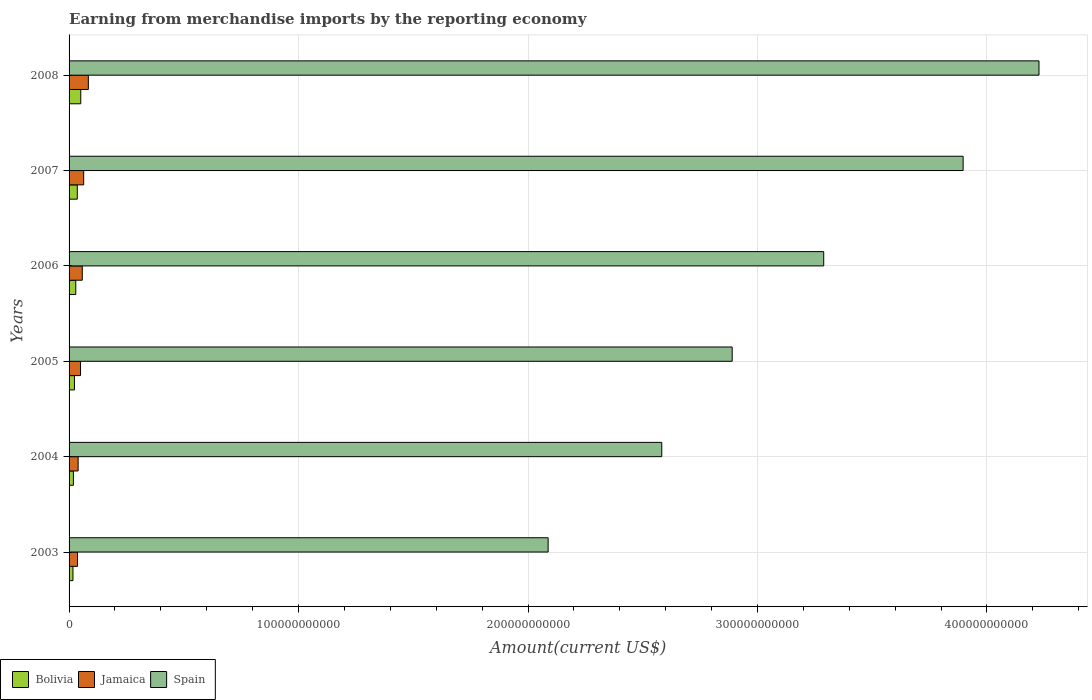Are the number of bars on each tick of the Y-axis equal?
Ensure brevity in your answer.  Yes. What is the amount earned from merchandise imports in Spain in 2007?
Offer a very short reply. 3.90e+11. Across all years, what is the maximum amount earned from merchandise imports in Jamaica?
Ensure brevity in your answer.  8.40e+09. Across all years, what is the minimum amount earned from merchandise imports in Spain?
Offer a very short reply. 2.09e+11. In which year was the amount earned from merchandise imports in Bolivia minimum?
Keep it short and to the point. 2003. What is the total amount earned from merchandise imports in Bolivia in the graph?
Keep it short and to the point. 1.75e+1. What is the difference between the amount earned from merchandise imports in Bolivia in 2003 and that in 2008?
Offer a very short reply. -3.41e+09. What is the difference between the amount earned from merchandise imports in Jamaica in 2008 and the amount earned from merchandise imports in Bolivia in 2007?
Make the answer very short. 4.81e+09. What is the average amount earned from merchandise imports in Jamaica per year?
Your answer should be compact. 5.52e+09. In the year 2008, what is the difference between the amount earned from merchandise imports in Spain and amount earned from merchandise imports in Jamaica?
Make the answer very short. 4.14e+11. What is the ratio of the amount earned from merchandise imports in Bolivia in 2003 to that in 2006?
Ensure brevity in your answer.  0.58. Is the amount earned from merchandise imports in Spain in 2003 less than that in 2006?
Make the answer very short. Yes. Is the difference between the amount earned from merchandise imports in Spain in 2006 and 2007 greater than the difference between the amount earned from merchandise imports in Jamaica in 2006 and 2007?
Ensure brevity in your answer.  No. What is the difference between the highest and the second highest amount earned from merchandise imports in Spain?
Your answer should be very brief. 3.31e+1. What is the difference between the highest and the lowest amount earned from merchandise imports in Bolivia?
Give a very brief answer. 3.41e+09. Is the sum of the amount earned from merchandise imports in Bolivia in 2005 and 2007 greater than the maximum amount earned from merchandise imports in Spain across all years?
Provide a succinct answer. No. What does the 2nd bar from the top in 2005 represents?
Give a very brief answer. Jamaica. What does the 1st bar from the bottom in 2007 represents?
Your answer should be very brief. Bolivia. How many years are there in the graph?
Ensure brevity in your answer.  6. What is the difference between two consecutive major ticks on the X-axis?
Make the answer very short. 1.00e+11. Are the values on the major ticks of X-axis written in scientific E-notation?
Your response must be concise. No. Does the graph contain any zero values?
Provide a succinct answer. No. Does the graph contain grids?
Ensure brevity in your answer.  Yes. Where does the legend appear in the graph?
Your answer should be very brief. Bottom left. How many legend labels are there?
Ensure brevity in your answer.  3. How are the legend labels stacked?
Your answer should be compact. Horizontal. What is the title of the graph?
Give a very brief answer. Earning from merchandise imports by the reporting economy. What is the label or title of the X-axis?
Offer a very short reply. Amount(current US$). What is the Amount(current US$) in Bolivia in 2003?
Offer a very short reply. 1.69e+09. What is the Amount(current US$) of Jamaica in 2003?
Provide a short and direct response. 3.67e+09. What is the Amount(current US$) in Spain in 2003?
Give a very brief answer. 2.09e+11. What is the Amount(current US$) in Bolivia in 2004?
Your answer should be compact. 1.89e+09. What is the Amount(current US$) of Jamaica in 2004?
Offer a very short reply. 3.95e+09. What is the Amount(current US$) of Spain in 2004?
Make the answer very short. 2.58e+11. What is the Amount(current US$) in Bolivia in 2005?
Provide a short and direct response. 2.34e+09. What is the Amount(current US$) in Jamaica in 2005?
Ensure brevity in your answer.  4.99e+09. What is the Amount(current US$) of Spain in 2005?
Your answer should be compact. 2.89e+11. What is the Amount(current US$) in Bolivia in 2006?
Give a very brief answer. 2.93e+09. What is the Amount(current US$) of Jamaica in 2006?
Offer a terse response. 5.75e+09. What is the Amount(current US$) in Spain in 2006?
Offer a very short reply. 3.29e+11. What is the Amount(current US$) of Bolivia in 2007?
Your answer should be compact. 3.59e+09. What is the Amount(current US$) in Jamaica in 2007?
Provide a short and direct response. 6.37e+09. What is the Amount(current US$) of Spain in 2007?
Your response must be concise. 3.90e+11. What is the Amount(current US$) in Bolivia in 2008?
Keep it short and to the point. 5.10e+09. What is the Amount(current US$) in Jamaica in 2008?
Provide a succinct answer. 8.40e+09. What is the Amount(current US$) in Spain in 2008?
Keep it short and to the point. 4.23e+11. Across all years, what is the maximum Amount(current US$) of Bolivia?
Provide a succinct answer. 5.10e+09. Across all years, what is the maximum Amount(current US$) in Jamaica?
Ensure brevity in your answer.  8.40e+09. Across all years, what is the maximum Amount(current US$) of Spain?
Offer a terse response. 4.23e+11. Across all years, what is the minimum Amount(current US$) of Bolivia?
Offer a very short reply. 1.69e+09. Across all years, what is the minimum Amount(current US$) in Jamaica?
Offer a very short reply. 3.67e+09. Across all years, what is the minimum Amount(current US$) of Spain?
Offer a terse response. 2.09e+11. What is the total Amount(current US$) in Bolivia in the graph?
Provide a succinct answer. 1.75e+1. What is the total Amount(current US$) in Jamaica in the graph?
Keep it short and to the point. 3.31e+1. What is the total Amount(current US$) in Spain in the graph?
Give a very brief answer. 1.90e+12. What is the difference between the Amount(current US$) in Bolivia in 2003 and that in 2004?
Ensure brevity in your answer.  -1.96e+08. What is the difference between the Amount(current US$) of Jamaica in 2003 and that in 2004?
Offer a very short reply. -2.81e+08. What is the difference between the Amount(current US$) of Spain in 2003 and that in 2004?
Ensure brevity in your answer.  -4.95e+1. What is the difference between the Amount(current US$) in Bolivia in 2003 and that in 2005?
Offer a very short reply. -6.51e+08. What is the difference between the Amount(current US$) in Jamaica in 2003 and that in 2005?
Provide a short and direct response. -1.32e+09. What is the difference between the Amount(current US$) of Spain in 2003 and that in 2005?
Make the answer very short. -8.02e+1. What is the difference between the Amount(current US$) of Bolivia in 2003 and that in 2006?
Give a very brief answer. -1.23e+09. What is the difference between the Amount(current US$) of Jamaica in 2003 and that in 2006?
Provide a succinct answer. -2.08e+09. What is the difference between the Amount(current US$) in Spain in 2003 and that in 2006?
Ensure brevity in your answer.  -1.20e+11. What is the difference between the Amount(current US$) of Bolivia in 2003 and that in 2007?
Your response must be concise. -1.90e+09. What is the difference between the Amount(current US$) of Jamaica in 2003 and that in 2007?
Offer a very short reply. -2.70e+09. What is the difference between the Amount(current US$) in Spain in 2003 and that in 2007?
Make the answer very short. -1.81e+11. What is the difference between the Amount(current US$) of Bolivia in 2003 and that in 2008?
Your response must be concise. -3.41e+09. What is the difference between the Amount(current US$) in Jamaica in 2003 and that in 2008?
Your answer should be very brief. -4.73e+09. What is the difference between the Amount(current US$) of Spain in 2003 and that in 2008?
Ensure brevity in your answer.  -2.14e+11. What is the difference between the Amount(current US$) in Bolivia in 2004 and that in 2005?
Your answer should be compact. -4.56e+08. What is the difference between the Amount(current US$) in Jamaica in 2004 and that in 2005?
Your response must be concise. -1.04e+09. What is the difference between the Amount(current US$) in Spain in 2004 and that in 2005?
Offer a very short reply. -3.07e+1. What is the difference between the Amount(current US$) of Bolivia in 2004 and that in 2006?
Make the answer very short. -1.04e+09. What is the difference between the Amount(current US$) of Jamaica in 2004 and that in 2006?
Give a very brief answer. -1.80e+09. What is the difference between the Amount(current US$) in Spain in 2004 and that in 2006?
Keep it short and to the point. -7.06e+1. What is the difference between the Amount(current US$) in Bolivia in 2004 and that in 2007?
Provide a succinct answer. -1.70e+09. What is the difference between the Amount(current US$) of Jamaica in 2004 and that in 2007?
Provide a succinct answer. -2.42e+09. What is the difference between the Amount(current US$) of Spain in 2004 and that in 2007?
Your answer should be compact. -1.31e+11. What is the difference between the Amount(current US$) in Bolivia in 2004 and that in 2008?
Provide a short and direct response. -3.21e+09. What is the difference between the Amount(current US$) of Jamaica in 2004 and that in 2008?
Give a very brief answer. -4.44e+09. What is the difference between the Amount(current US$) in Spain in 2004 and that in 2008?
Ensure brevity in your answer.  -1.64e+11. What is the difference between the Amount(current US$) in Bolivia in 2005 and that in 2006?
Your answer should be very brief. -5.82e+08. What is the difference between the Amount(current US$) in Jamaica in 2005 and that in 2006?
Provide a succinct answer. -7.57e+08. What is the difference between the Amount(current US$) of Spain in 2005 and that in 2006?
Keep it short and to the point. -3.99e+1. What is the difference between the Amount(current US$) in Bolivia in 2005 and that in 2007?
Make the answer very short. -1.24e+09. What is the difference between the Amount(current US$) of Jamaica in 2005 and that in 2007?
Make the answer very short. -1.38e+09. What is the difference between the Amount(current US$) in Spain in 2005 and that in 2007?
Provide a succinct answer. -1.01e+11. What is the difference between the Amount(current US$) of Bolivia in 2005 and that in 2008?
Make the answer very short. -2.76e+09. What is the difference between the Amount(current US$) in Jamaica in 2005 and that in 2008?
Ensure brevity in your answer.  -3.41e+09. What is the difference between the Amount(current US$) of Spain in 2005 and that in 2008?
Ensure brevity in your answer.  -1.34e+11. What is the difference between the Amount(current US$) of Bolivia in 2006 and that in 2007?
Make the answer very short. -6.62e+08. What is the difference between the Amount(current US$) in Jamaica in 2006 and that in 2007?
Provide a short and direct response. -6.19e+08. What is the difference between the Amount(current US$) of Spain in 2006 and that in 2007?
Your answer should be very brief. -6.07e+1. What is the difference between the Amount(current US$) in Bolivia in 2006 and that in 2008?
Provide a short and direct response. -2.17e+09. What is the difference between the Amount(current US$) of Jamaica in 2006 and that in 2008?
Provide a short and direct response. -2.65e+09. What is the difference between the Amount(current US$) of Spain in 2006 and that in 2008?
Provide a short and direct response. -9.38e+1. What is the difference between the Amount(current US$) of Bolivia in 2007 and that in 2008?
Give a very brief answer. -1.51e+09. What is the difference between the Amount(current US$) in Jamaica in 2007 and that in 2008?
Keep it short and to the point. -2.03e+09. What is the difference between the Amount(current US$) of Spain in 2007 and that in 2008?
Ensure brevity in your answer.  -3.31e+1. What is the difference between the Amount(current US$) in Bolivia in 2003 and the Amount(current US$) in Jamaica in 2004?
Your answer should be compact. -2.26e+09. What is the difference between the Amount(current US$) in Bolivia in 2003 and the Amount(current US$) in Spain in 2004?
Provide a short and direct response. -2.57e+11. What is the difference between the Amount(current US$) in Jamaica in 2003 and the Amount(current US$) in Spain in 2004?
Make the answer very short. -2.55e+11. What is the difference between the Amount(current US$) of Bolivia in 2003 and the Amount(current US$) of Jamaica in 2005?
Your answer should be compact. -3.30e+09. What is the difference between the Amount(current US$) in Bolivia in 2003 and the Amount(current US$) in Spain in 2005?
Keep it short and to the point. -2.87e+11. What is the difference between the Amount(current US$) in Jamaica in 2003 and the Amount(current US$) in Spain in 2005?
Your answer should be very brief. -2.85e+11. What is the difference between the Amount(current US$) in Bolivia in 2003 and the Amount(current US$) in Jamaica in 2006?
Your answer should be compact. -4.06e+09. What is the difference between the Amount(current US$) of Bolivia in 2003 and the Amount(current US$) of Spain in 2006?
Make the answer very short. -3.27e+11. What is the difference between the Amount(current US$) in Jamaica in 2003 and the Amount(current US$) in Spain in 2006?
Your answer should be very brief. -3.25e+11. What is the difference between the Amount(current US$) in Bolivia in 2003 and the Amount(current US$) in Jamaica in 2007?
Ensure brevity in your answer.  -4.68e+09. What is the difference between the Amount(current US$) in Bolivia in 2003 and the Amount(current US$) in Spain in 2007?
Your answer should be compact. -3.88e+11. What is the difference between the Amount(current US$) in Jamaica in 2003 and the Amount(current US$) in Spain in 2007?
Make the answer very short. -3.86e+11. What is the difference between the Amount(current US$) in Bolivia in 2003 and the Amount(current US$) in Jamaica in 2008?
Keep it short and to the point. -6.71e+09. What is the difference between the Amount(current US$) of Bolivia in 2003 and the Amount(current US$) of Spain in 2008?
Provide a succinct answer. -4.21e+11. What is the difference between the Amount(current US$) in Jamaica in 2003 and the Amount(current US$) in Spain in 2008?
Offer a very short reply. -4.19e+11. What is the difference between the Amount(current US$) of Bolivia in 2004 and the Amount(current US$) of Jamaica in 2005?
Give a very brief answer. -3.10e+09. What is the difference between the Amount(current US$) in Bolivia in 2004 and the Amount(current US$) in Spain in 2005?
Keep it short and to the point. -2.87e+11. What is the difference between the Amount(current US$) in Jamaica in 2004 and the Amount(current US$) in Spain in 2005?
Your answer should be compact. -2.85e+11. What is the difference between the Amount(current US$) of Bolivia in 2004 and the Amount(current US$) of Jamaica in 2006?
Provide a succinct answer. -3.86e+09. What is the difference between the Amount(current US$) in Bolivia in 2004 and the Amount(current US$) in Spain in 2006?
Provide a succinct answer. -3.27e+11. What is the difference between the Amount(current US$) of Jamaica in 2004 and the Amount(current US$) of Spain in 2006?
Offer a terse response. -3.25e+11. What is the difference between the Amount(current US$) of Bolivia in 2004 and the Amount(current US$) of Jamaica in 2007?
Provide a short and direct response. -4.48e+09. What is the difference between the Amount(current US$) of Bolivia in 2004 and the Amount(current US$) of Spain in 2007?
Provide a succinct answer. -3.88e+11. What is the difference between the Amount(current US$) of Jamaica in 2004 and the Amount(current US$) of Spain in 2007?
Make the answer very short. -3.86e+11. What is the difference between the Amount(current US$) of Bolivia in 2004 and the Amount(current US$) of Jamaica in 2008?
Keep it short and to the point. -6.51e+09. What is the difference between the Amount(current US$) in Bolivia in 2004 and the Amount(current US$) in Spain in 2008?
Your answer should be very brief. -4.21e+11. What is the difference between the Amount(current US$) of Jamaica in 2004 and the Amount(current US$) of Spain in 2008?
Your answer should be very brief. -4.19e+11. What is the difference between the Amount(current US$) in Bolivia in 2005 and the Amount(current US$) in Jamaica in 2006?
Give a very brief answer. -3.41e+09. What is the difference between the Amount(current US$) of Bolivia in 2005 and the Amount(current US$) of Spain in 2006?
Offer a terse response. -3.27e+11. What is the difference between the Amount(current US$) of Jamaica in 2005 and the Amount(current US$) of Spain in 2006?
Your answer should be very brief. -3.24e+11. What is the difference between the Amount(current US$) in Bolivia in 2005 and the Amount(current US$) in Jamaica in 2007?
Make the answer very short. -4.02e+09. What is the difference between the Amount(current US$) of Bolivia in 2005 and the Amount(current US$) of Spain in 2007?
Offer a terse response. -3.87e+11. What is the difference between the Amount(current US$) of Jamaica in 2005 and the Amount(current US$) of Spain in 2007?
Your answer should be compact. -3.85e+11. What is the difference between the Amount(current US$) in Bolivia in 2005 and the Amount(current US$) in Jamaica in 2008?
Your response must be concise. -6.05e+09. What is the difference between the Amount(current US$) in Bolivia in 2005 and the Amount(current US$) in Spain in 2008?
Keep it short and to the point. -4.20e+11. What is the difference between the Amount(current US$) in Jamaica in 2005 and the Amount(current US$) in Spain in 2008?
Keep it short and to the point. -4.18e+11. What is the difference between the Amount(current US$) of Bolivia in 2006 and the Amount(current US$) of Jamaica in 2007?
Your response must be concise. -3.44e+09. What is the difference between the Amount(current US$) in Bolivia in 2006 and the Amount(current US$) in Spain in 2007?
Your response must be concise. -3.87e+11. What is the difference between the Amount(current US$) of Jamaica in 2006 and the Amount(current US$) of Spain in 2007?
Offer a terse response. -3.84e+11. What is the difference between the Amount(current US$) of Bolivia in 2006 and the Amount(current US$) of Jamaica in 2008?
Ensure brevity in your answer.  -5.47e+09. What is the difference between the Amount(current US$) in Bolivia in 2006 and the Amount(current US$) in Spain in 2008?
Keep it short and to the point. -4.20e+11. What is the difference between the Amount(current US$) in Jamaica in 2006 and the Amount(current US$) in Spain in 2008?
Your answer should be very brief. -4.17e+11. What is the difference between the Amount(current US$) of Bolivia in 2007 and the Amount(current US$) of Jamaica in 2008?
Offer a terse response. -4.81e+09. What is the difference between the Amount(current US$) in Bolivia in 2007 and the Amount(current US$) in Spain in 2008?
Your answer should be compact. -4.19e+11. What is the difference between the Amount(current US$) of Jamaica in 2007 and the Amount(current US$) of Spain in 2008?
Ensure brevity in your answer.  -4.16e+11. What is the average Amount(current US$) of Bolivia per year?
Your answer should be compact. 2.92e+09. What is the average Amount(current US$) in Jamaica per year?
Provide a succinct answer. 5.52e+09. What is the average Amount(current US$) in Spain per year?
Offer a terse response. 3.16e+11. In the year 2003, what is the difference between the Amount(current US$) of Bolivia and Amount(current US$) of Jamaica?
Give a very brief answer. -1.98e+09. In the year 2003, what is the difference between the Amount(current US$) of Bolivia and Amount(current US$) of Spain?
Offer a very short reply. -2.07e+11. In the year 2003, what is the difference between the Amount(current US$) of Jamaica and Amount(current US$) of Spain?
Make the answer very short. -2.05e+11. In the year 2004, what is the difference between the Amount(current US$) of Bolivia and Amount(current US$) of Jamaica?
Your answer should be compact. -2.07e+09. In the year 2004, what is the difference between the Amount(current US$) in Bolivia and Amount(current US$) in Spain?
Make the answer very short. -2.56e+11. In the year 2004, what is the difference between the Amount(current US$) in Jamaica and Amount(current US$) in Spain?
Your answer should be compact. -2.54e+11. In the year 2005, what is the difference between the Amount(current US$) of Bolivia and Amount(current US$) of Jamaica?
Provide a succinct answer. -2.65e+09. In the year 2005, what is the difference between the Amount(current US$) in Bolivia and Amount(current US$) in Spain?
Keep it short and to the point. -2.87e+11. In the year 2005, what is the difference between the Amount(current US$) in Jamaica and Amount(current US$) in Spain?
Offer a very short reply. -2.84e+11. In the year 2006, what is the difference between the Amount(current US$) in Bolivia and Amount(current US$) in Jamaica?
Keep it short and to the point. -2.82e+09. In the year 2006, what is the difference between the Amount(current US$) in Bolivia and Amount(current US$) in Spain?
Provide a short and direct response. -3.26e+11. In the year 2006, what is the difference between the Amount(current US$) of Jamaica and Amount(current US$) of Spain?
Ensure brevity in your answer.  -3.23e+11. In the year 2007, what is the difference between the Amount(current US$) in Bolivia and Amount(current US$) in Jamaica?
Keep it short and to the point. -2.78e+09. In the year 2007, what is the difference between the Amount(current US$) in Bolivia and Amount(current US$) in Spain?
Provide a succinct answer. -3.86e+11. In the year 2007, what is the difference between the Amount(current US$) in Jamaica and Amount(current US$) in Spain?
Provide a short and direct response. -3.83e+11. In the year 2008, what is the difference between the Amount(current US$) in Bolivia and Amount(current US$) in Jamaica?
Give a very brief answer. -3.30e+09. In the year 2008, what is the difference between the Amount(current US$) in Bolivia and Amount(current US$) in Spain?
Make the answer very short. -4.18e+11. In the year 2008, what is the difference between the Amount(current US$) of Jamaica and Amount(current US$) of Spain?
Ensure brevity in your answer.  -4.14e+11. What is the ratio of the Amount(current US$) of Bolivia in 2003 to that in 2004?
Keep it short and to the point. 0.9. What is the ratio of the Amount(current US$) in Jamaica in 2003 to that in 2004?
Keep it short and to the point. 0.93. What is the ratio of the Amount(current US$) in Spain in 2003 to that in 2004?
Your response must be concise. 0.81. What is the ratio of the Amount(current US$) in Bolivia in 2003 to that in 2005?
Offer a very short reply. 0.72. What is the ratio of the Amount(current US$) of Jamaica in 2003 to that in 2005?
Provide a succinct answer. 0.74. What is the ratio of the Amount(current US$) in Spain in 2003 to that in 2005?
Offer a very short reply. 0.72. What is the ratio of the Amount(current US$) of Bolivia in 2003 to that in 2006?
Your response must be concise. 0.58. What is the ratio of the Amount(current US$) in Jamaica in 2003 to that in 2006?
Your answer should be very brief. 0.64. What is the ratio of the Amount(current US$) in Spain in 2003 to that in 2006?
Provide a succinct answer. 0.63. What is the ratio of the Amount(current US$) of Bolivia in 2003 to that in 2007?
Give a very brief answer. 0.47. What is the ratio of the Amount(current US$) of Jamaica in 2003 to that in 2007?
Ensure brevity in your answer.  0.58. What is the ratio of the Amount(current US$) of Spain in 2003 to that in 2007?
Provide a short and direct response. 0.54. What is the ratio of the Amount(current US$) in Bolivia in 2003 to that in 2008?
Offer a very short reply. 0.33. What is the ratio of the Amount(current US$) in Jamaica in 2003 to that in 2008?
Provide a short and direct response. 0.44. What is the ratio of the Amount(current US$) of Spain in 2003 to that in 2008?
Provide a short and direct response. 0.49. What is the ratio of the Amount(current US$) of Bolivia in 2004 to that in 2005?
Make the answer very short. 0.81. What is the ratio of the Amount(current US$) in Jamaica in 2004 to that in 2005?
Your answer should be compact. 0.79. What is the ratio of the Amount(current US$) in Spain in 2004 to that in 2005?
Your response must be concise. 0.89. What is the ratio of the Amount(current US$) in Bolivia in 2004 to that in 2006?
Your response must be concise. 0.65. What is the ratio of the Amount(current US$) in Jamaica in 2004 to that in 2006?
Make the answer very short. 0.69. What is the ratio of the Amount(current US$) in Spain in 2004 to that in 2006?
Provide a short and direct response. 0.79. What is the ratio of the Amount(current US$) of Bolivia in 2004 to that in 2007?
Give a very brief answer. 0.53. What is the ratio of the Amount(current US$) of Jamaica in 2004 to that in 2007?
Your response must be concise. 0.62. What is the ratio of the Amount(current US$) in Spain in 2004 to that in 2007?
Keep it short and to the point. 0.66. What is the ratio of the Amount(current US$) in Bolivia in 2004 to that in 2008?
Offer a terse response. 0.37. What is the ratio of the Amount(current US$) in Jamaica in 2004 to that in 2008?
Your answer should be compact. 0.47. What is the ratio of the Amount(current US$) in Spain in 2004 to that in 2008?
Your answer should be very brief. 0.61. What is the ratio of the Amount(current US$) of Bolivia in 2005 to that in 2006?
Your answer should be very brief. 0.8. What is the ratio of the Amount(current US$) of Jamaica in 2005 to that in 2006?
Your response must be concise. 0.87. What is the ratio of the Amount(current US$) in Spain in 2005 to that in 2006?
Provide a short and direct response. 0.88. What is the ratio of the Amount(current US$) in Bolivia in 2005 to that in 2007?
Offer a very short reply. 0.65. What is the ratio of the Amount(current US$) of Jamaica in 2005 to that in 2007?
Make the answer very short. 0.78. What is the ratio of the Amount(current US$) of Spain in 2005 to that in 2007?
Your answer should be very brief. 0.74. What is the ratio of the Amount(current US$) in Bolivia in 2005 to that in 2008?
Give a very brief answer. 0.46. What is the ratio of the Amount(current US$) in Jamaica in 2005 to that in 2008?
Your answer should be very brief. 0.59. What is the ratio of the Amount(current US$) in Spain in 2005 to that in 2008?
Keep it short and to the point. 0.68. What is the ratio of the Amount(current US$) in Bolivia in 2006 to that in 2007?
Make the answer very short. 0.82. What is the ratio of the Amount(current US$) of Jamaica in 2006 to that in 2007?
Offer a terse response. 0.9. What is the ratio of the Amount(current US$) of Spain in 2006 to that in 2007?
Offer a very short reply. 0.84. What is the ratio of the Amount(current US$) of Bolivia in 2006 to that in 2008?
Make the answer very short. 0.57. What is the ratio of the Amount(current US$) in Jamaica in 2006 to that in 2008?
Provide a short and direct response. 0.68. What is the ratio of the Amount(current US$) of Spain in 2006 to that in 2008?
Offer a very short reply. 0.78. What is the ratio of the Amount(current US$) of Bolivia in 2007 to that in 2008?
Provide a short and direct response. 0.7. What is the ratio of the Amount(current US$) of Jamaica in 2007 to that in 2008?
Your answer should be compact. 0.76. What is the ratio of the Amount(current US$) in Spain in 2007 to that in 2008?
Make the answer very short. 0.92. What is the difference between the highest and the second highest Amount(current US$) of Bolivia?
Make the answer very short. 1.51e+09. What is the difference between the highest and the second highest Amount(current US$) in Jamaica?
Provide a short and direct response. 2.03e+09. What is the difference between the highest and the second highest Amount(current US$) in Spain?
Offer a terse response. 3.31e+1. What is the difference between the highest and the lowest Amount(current US$) of Bolivia?
Your answer should be very brief. 3.41e+09. What is the difference between the highest and the lowest Amount(current US$) in Jamaica?
Give a very brief answer. 4.73e+09. What is the difference between the highest and the lowest Amount(current US$) in Spain?
Offer a very short reply. 2.14e+11. 